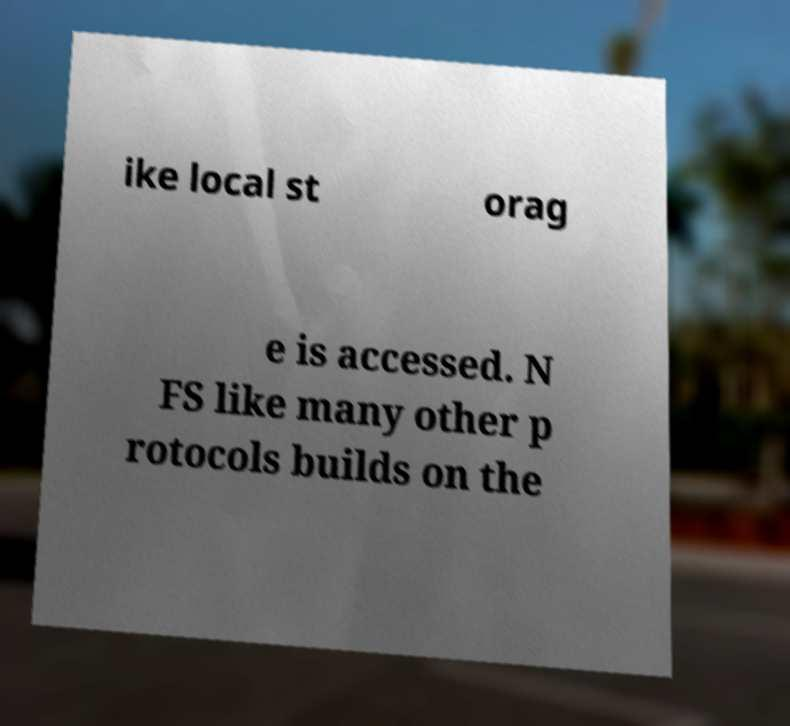What messages or text are displayed in this image? I need them in a readable, typed format. ike local st orag e is accessed. N FS like many other p rotocols builds on the 